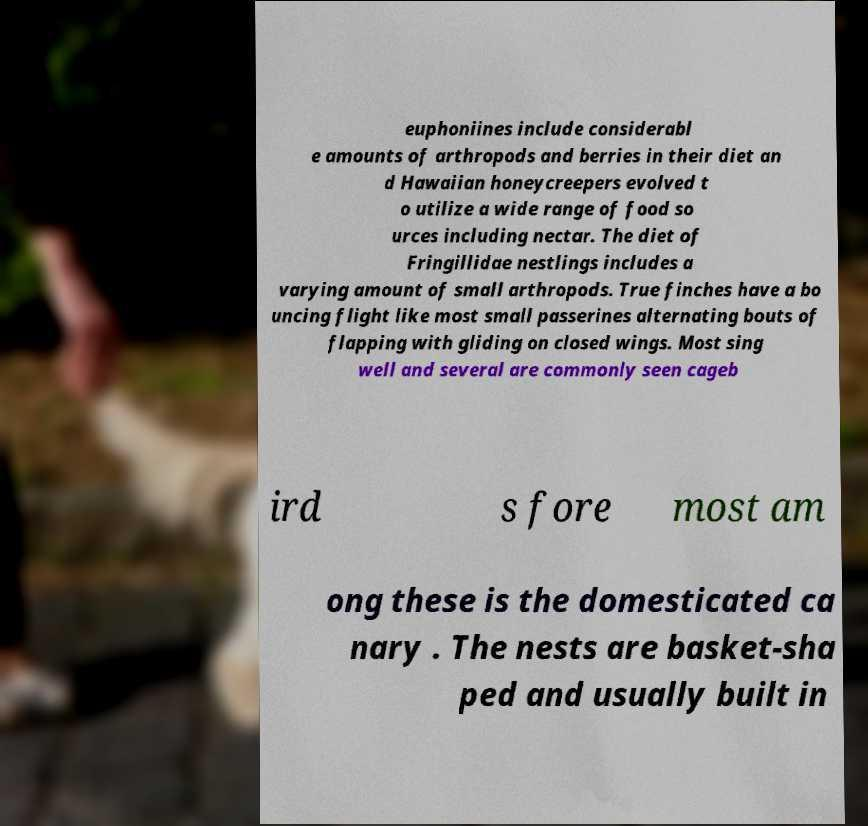For documentation purposes, I need the text within this image transcribed. Could you provide that? euphoniines include considerabl e amounts of arthropods and berries in their diet an d Hawaiian honeycreepers evolved t o utilize a wide range of food so urces including nectar. The diet of Fringillidae nestlings includes a varying amount of small arthropods. True finches have a bo uncing flight like most small passerines alternating bouts of flapping with gliding on closed wings. Most sing well and several are commonly seen cageb ird s fore most am ong these is the domesticated ca nary . The nests are basket-sha ped and usually built in 